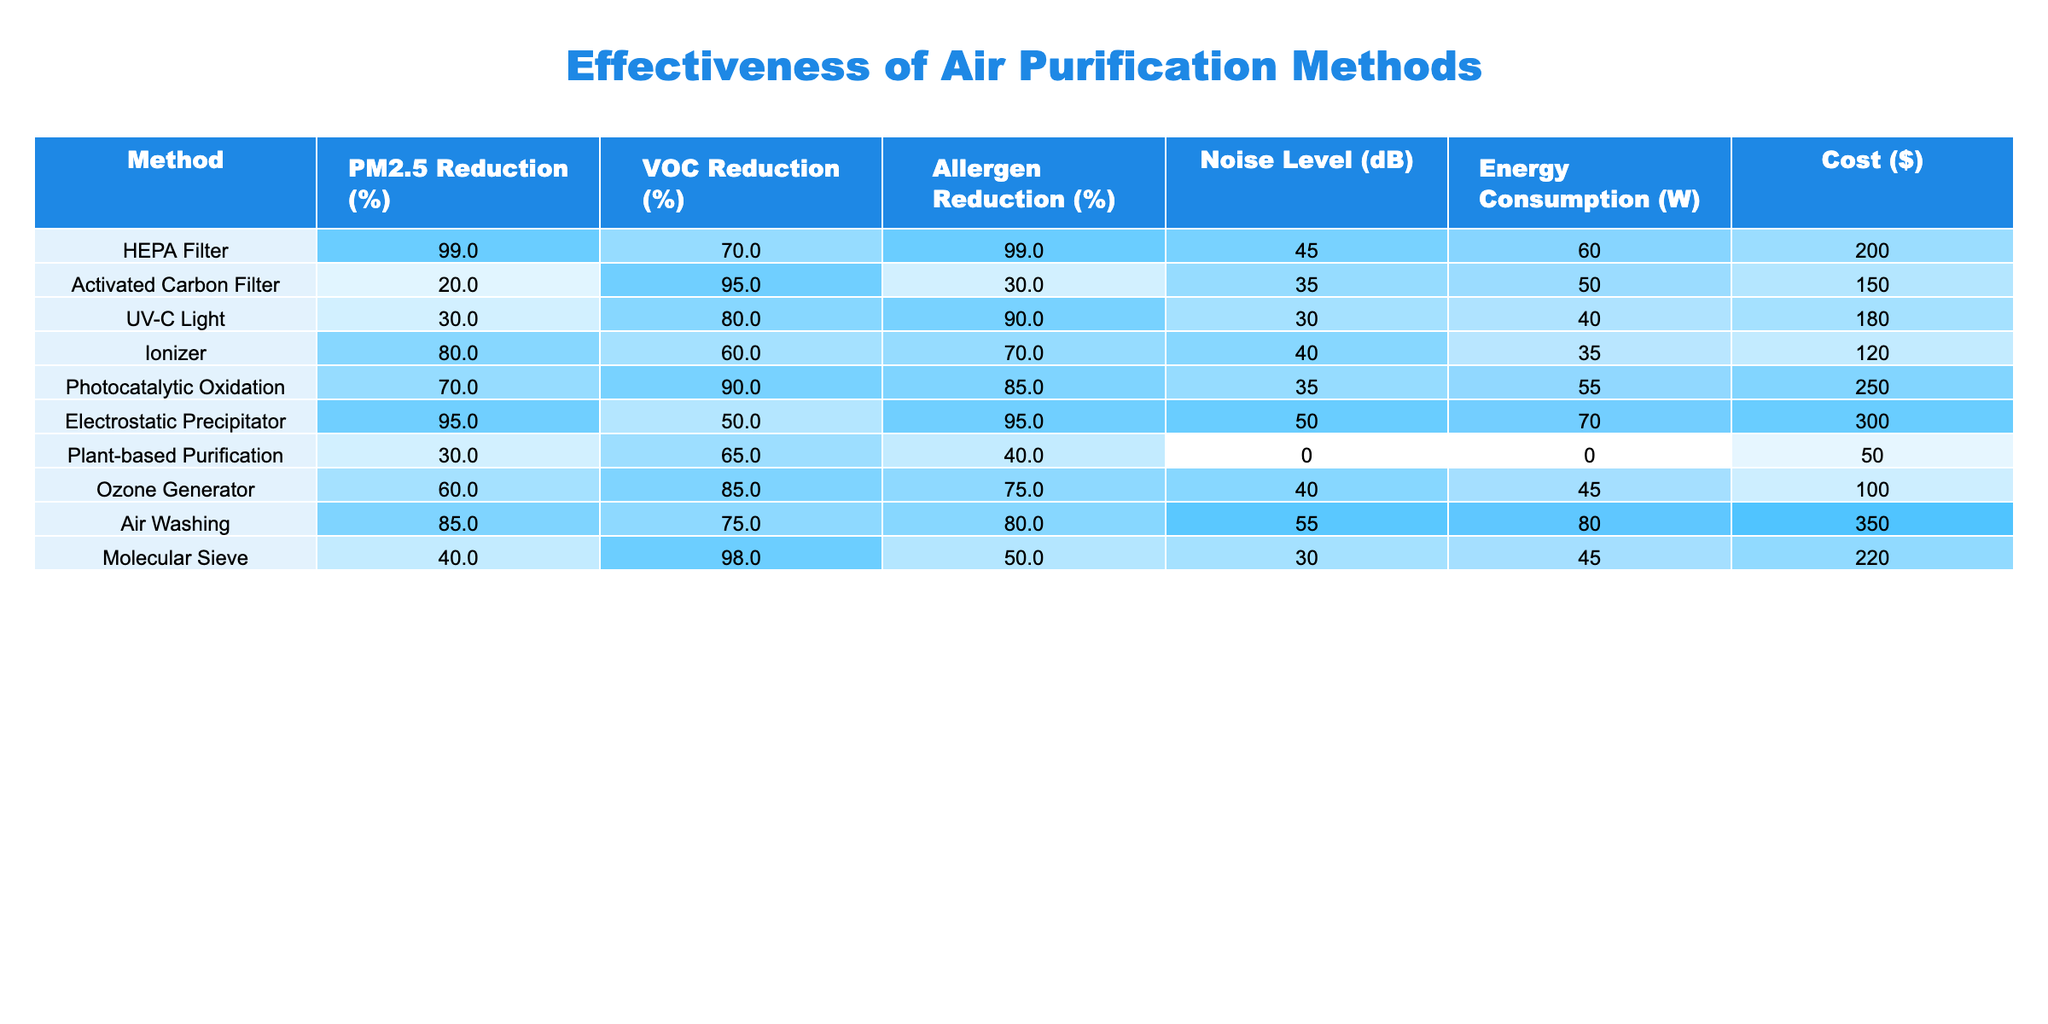What is the PM2.5 reduction percentage for the HEPA Filter? The HEPA Filter row in the table lists a PM2.5 Reduction of 99%.
Answer: 99% Which air purification method has the highest allergen reduction percentage? Looking at the Allergen Reduction column, both the HEPA Filter and Electrostatic Precipitator have a reduction of 95%, which is the highest percentage.
Answer: HEPA Filter and Electrostatic Precipitator What is the cost of the Ionizer? The Ionizer row shows a Cost of $120.
Answer: $120 What is the average VOC reduction percentage for all methods? To find the average, sum the VOC Reduction percentages (70 + 95 + 80 + 60 + 90 + 50 + 65 + 85 + 75 + 98 =  955) and divide by the total number of methods (10), resulting in an average of 95.5%.
Answer: 95.5% Which method consumes the least energy? By comparing the Energy Consumption column, the Plant-based Purification method shows 0 W, which is the least energy consumption among all methods.
Answer: Plant-based Purification Is the Noise Level of the Air Washing method higher than that of the UV-C Light? The Air Washing method has a Noise Level of 55 dB while the UV-C Light has a Noise Level of 30 dB. Since 55 is greater than 30, the statement is true.
Answer: Yes Which purification method has the best combination of PM2.5 and VOC reduction? The HEPA Filter achieves 99% PM2.5 Reduction and 70% VOC Reduction, the highest PM2.5 reduction, but among the others, the Activated Carbon Filter offers a high 95% VOC reduction. Comparatively, the Electrostatic Precipitator has 95% PM2.5 reduction and 50% VOC reduction. To compare properly, the HEPA Filter has the best PM2.5 reduction but lesser VOC reduction than the Activated Carbon Filter. Therefore, no single method is the best in both categories.
Answer: None If I wanted to reduce indoor allergens to above 80%, which methods could I choose? Checking the Allergen Reduction column, any method with a percentage above 80% includes HEPA Filter (99%), UV-C Light (90%), Electrostatic Precipitator (95%), and Photocatalytic Oxidation (85%).
Answer: HEPA Filter, UV-C Light, Electrostatic Precipitator, Photocatalytic Oxidation How much more does the Electrostatic Precipitator cost compared to the Ionizer? The cost of Electrostatic Precipitator is $300, while the Ionizer costs $120. The difference is $300 - $120 = $180.
Answer: $180 Does the Ozone Generator have a higher reduction percentage for VOC than the Ionizer? The Ozone Generator shows a VOC Reduction of 85% whereas the Ionizer shows a reduction of 60%. Since 85% is greater than 60%, the statement is true.
Answer: Yes 